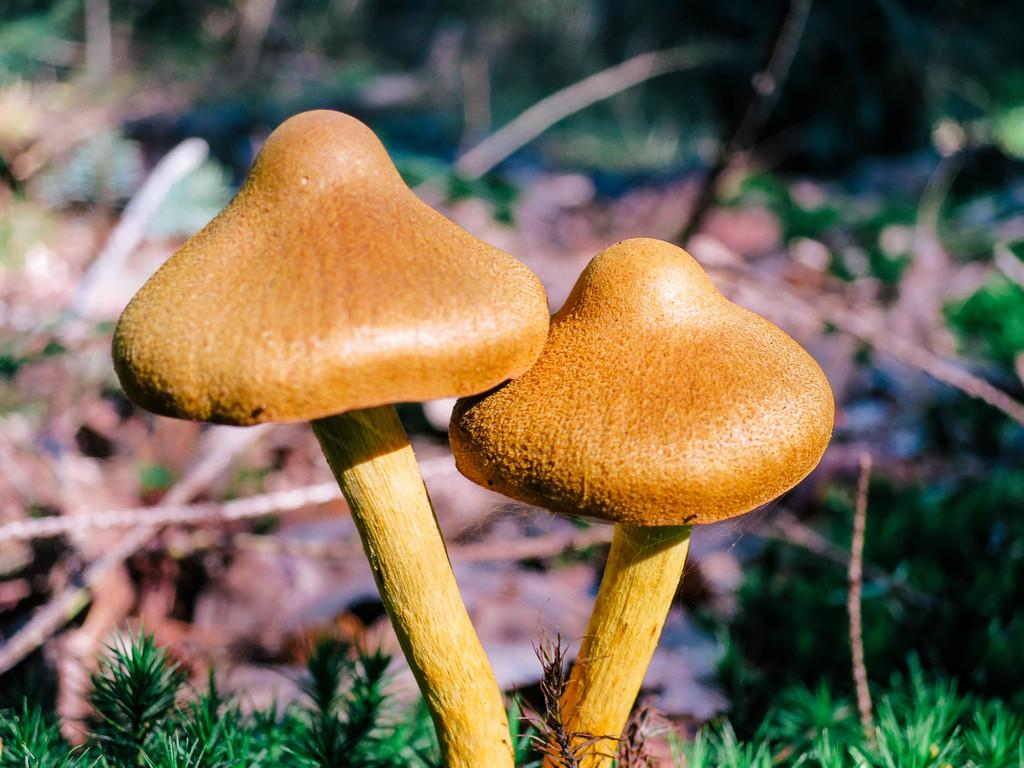What type of vegetation is present in the image? There are mushrooms and grass in the image. Can you describe the background of the image? The background of the image is blurred. What type of popcorn can be seen growing among the mushrooms in the image? There is no popcorn present in the image; it only features mushrooms and grass. Can you see any ducks swimming in the grass in the image? There are no ducks present in the image, and the grass is not depicted as a body of water. 